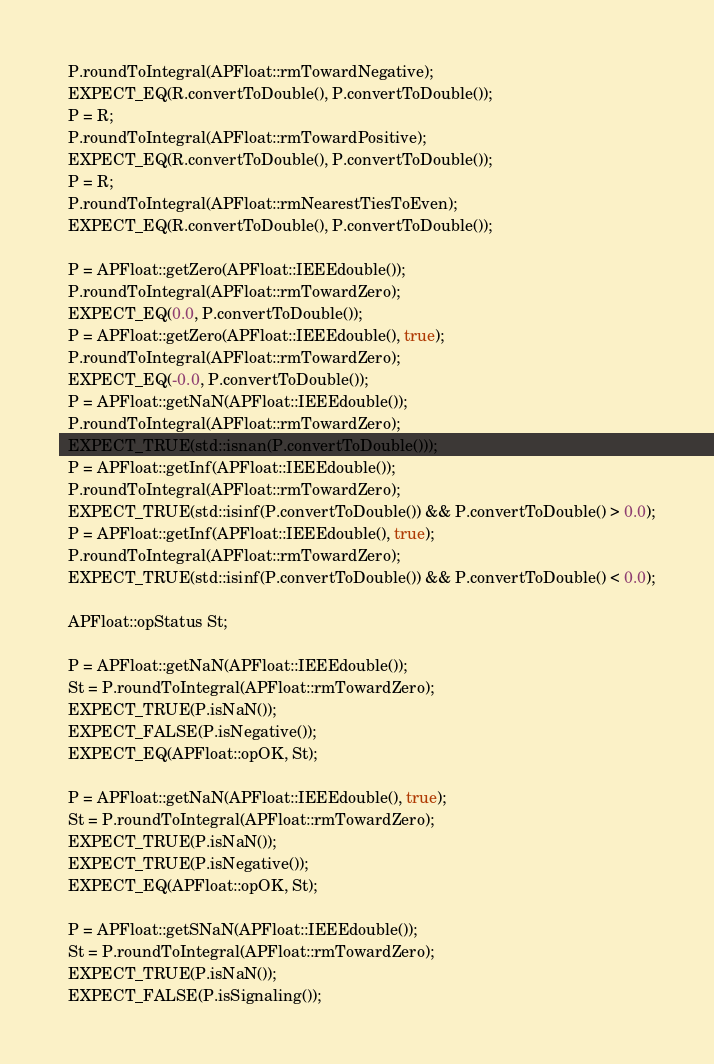<code> <loc_0><loc_0><loc_500><loc_500><_C++_>  P.roundToIntegral(APFloat::rmTowardNegative);
  EXPECT_EQ(R.convertToDouble(), P.convertToDouble());
  P = R;
  P.roundToIntegral(APFloat::rmTowardPositive);
  EXPECT_EQ(R.convertToDouble(), P.convertToDouble());
  P = R;
  P.roundToIntegral(APFloat::rmNearestTiesToEven);
  EXPECT_EQ(R.convertToDouble(), P.convertToDouble());

  P = APFloat::getZero(APFloat::IEEEdouble());
  P.roundToIntegral(APFloat::rmTowardZero);
  EXPECT_EQ(0.0, P.convertToDouble());
  P = APFloat::getZero(APFloat::IEEEdouble(), true);
  P.roundToIntegral(APFloat::rmTowardZero);
  EXPECT_EQ(-0.0, P.convertToDouble());
  P = APFloat::getNaN(APFloat::IEEEdouble());
  P.roundToIntegral(APFloat::rmTowardZero);
  EXPECT_TRUE(std::isnan(P.convertToDouble()));
  P = APFloat::getInf(APFloat::IEEEdouble());
  P.roundToIntegral(APFloat::rmTowardZero);
  EXPECT_TRUE(std::isinf(P.convertToDouble()) && P.convertToDouble() > 0.0);
  P = APFloat::getInf(APFloat::IEEEdouble(), true);
  P.roundToIntegral(APFloat::rmTowardZero);
  EXPECT_TRUE(std::isinf(P.convertToDouble()) && P.convertToDouble() < 0.0);

  APFloat::opStatus St;

  P = APFloat::getNaN(APFloat::IEEEdouble());
  St = P.roundToIntegral(APFloat::rmTowardZero);
  EXPECT_TRUE(P.isNaN());
  EXPECT_FALSE(P.isNegative());
  EXPECT_EQ(APFloat::opOK, St);

  P = APFloat::getNaN(APFloat::IEEEdouble(), true);
  St = P.roundToIntegral(APFloat::rmTowardZero);
  EXPECT_TRUE(P.isNaN());
  EXPECT_TRUE(P.isNegative());
  EXPECT_EQ(APFloat::opOK, St);

  P = APFloat::getSNaN(APFloat::IEEEdouble());
  St = P.roundToIntegral(APFloat::rmTowardZero);
  EXPECT_TRUE(P.isNaN());
  EXPECT_FALSE(P.isSignaling());</code> 